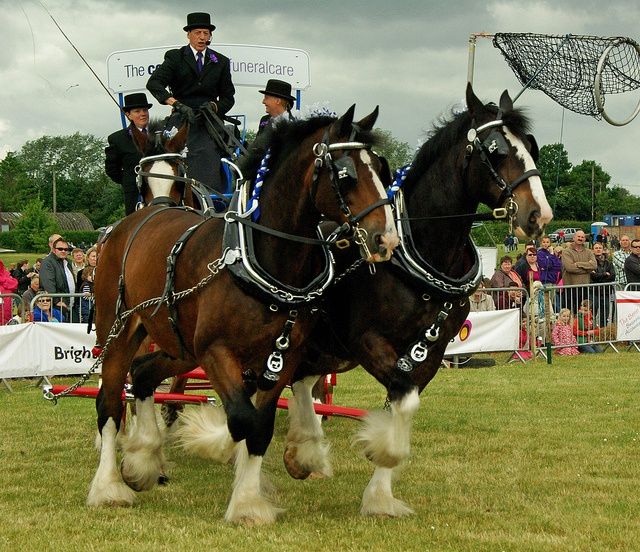Describe the objects in this image and their specific colors. I can see horse in darkgray, black, maroon, olive, and tan tones, horse in darkgray, black, olive, and gray tones, people in darkgray, black, tan, olive, and gray tones, people in darkgray, black, beige, gray, and brown tones, and people in darkgray, black, olive, maroon, and brown tones in this image. 